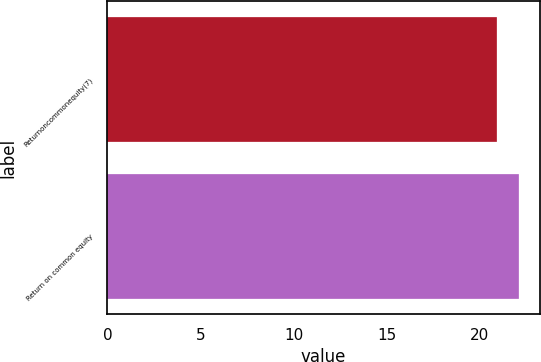Convert chart to OTSL. <chart><loc_0><loc_0><loc_500><loc_500><bar_chart><fcel>Returnoncommonequity(7)<fcel>Return on common equity<nl><fcel>20.9<fcel>22.1<nl></chart> 